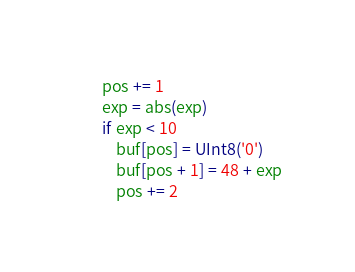<code> <loc_0><loc_0><loc_500><loc_500><_Julia_>        pos += 1
        exp = abs(exp)
        if exp < 10
            buf[pos] = UInt8('0')
            buf[pos + 1] = 48 + exp
            pos += 2</code> 